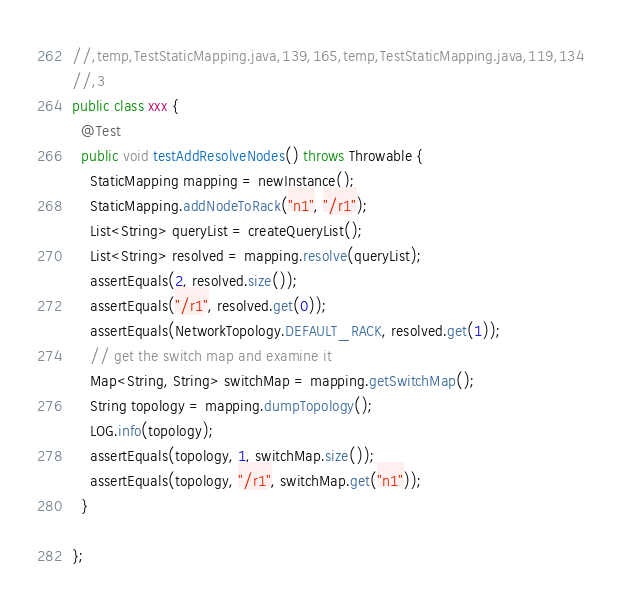<code> <loc_0><loc_0><loc_500><loc_500><_Java_>//,temp,TestStaticMapping.java,139,165,temp,TestStaticMapping.java,119,134
//,3
public class xxx {
  @Test
  public void testAddResolveNodes() throws Throwable {
    StaticMapping mapping = newInstance();
    StaticMapping.addNodeToRack("n1", "/r1");
    List<String> queryList = createQueryList();
    List<String> resolved = mapping.resolve(queryList);
    assertEquals(2, resolved.size());
    assertEquals("/r1", resolved.get(0));
    assertEquals(NetworkTopology.DEFAULT_RACK, resolved.get(1));
    // get the switch map and examine it
    Map<String, String> switchMap = mapping.getSwitchMap();
    String topology = mapping.dumpTopology();
    LOG.info(topology);
    assertEquals(topology, 1, switchMap.size());
    assertEquals(topology, "/r1", switchMap.get("n1"));
  }

};</code> 